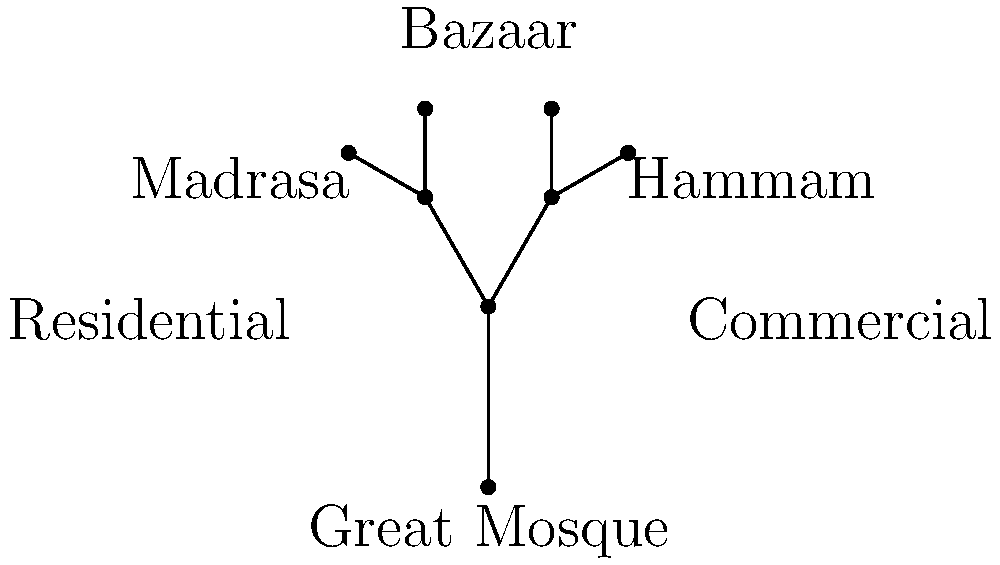In the tree diagram representing the hierarchical structure of public spaces in Islamic urban planning, what is the maximum depth of the tree from the root node (Great Mosque) to the furthest leaf node, and what does this depth signify in terms of urban organization? To answer this question, we need to analyze the tree diagram and understand its structure in relation to Islamic urban planning:

1. Identify the root node: The Great Mosque is at the base of the tree, representing the central point of the Islamic city.

2. Count the levels:
   - Level 1: Great Mosque (root)
   - Level 2: Bazaar (main branch)
   - Level 3: Madrasa and Hammam (secondary branches)
   - Level 4: Residential and Commercial areas (tertiary branches)

3. Determine the maximum depth: The tree has a maximum depth of 4 levels from the root to the furthest leaf nodes.

4. Interpret the significance:
   - The depth represents the hierarchical organization of urban spaces in Islamic cities.
   - Each level corresponds to a different category of public or semi-public space.
   - The structure reflects the principle of centrality in Islamic urban design, with the mosque as the focal point.
   - The branching pattern shows how different functions are distributed outward from the religious center.
   - This hierarchy ensures that essential services and spaces are organized in a logical and accessible manner, promoting social cohesion and efficient city functioning.

The maximum depth of 4 levels signifies a well-structured urban plan that balances centralization with functional distribution, a key characteristic of traditional Islamic city design.
Answer: 4 levels; hierarchical distribution of urban functions from religious center outward 